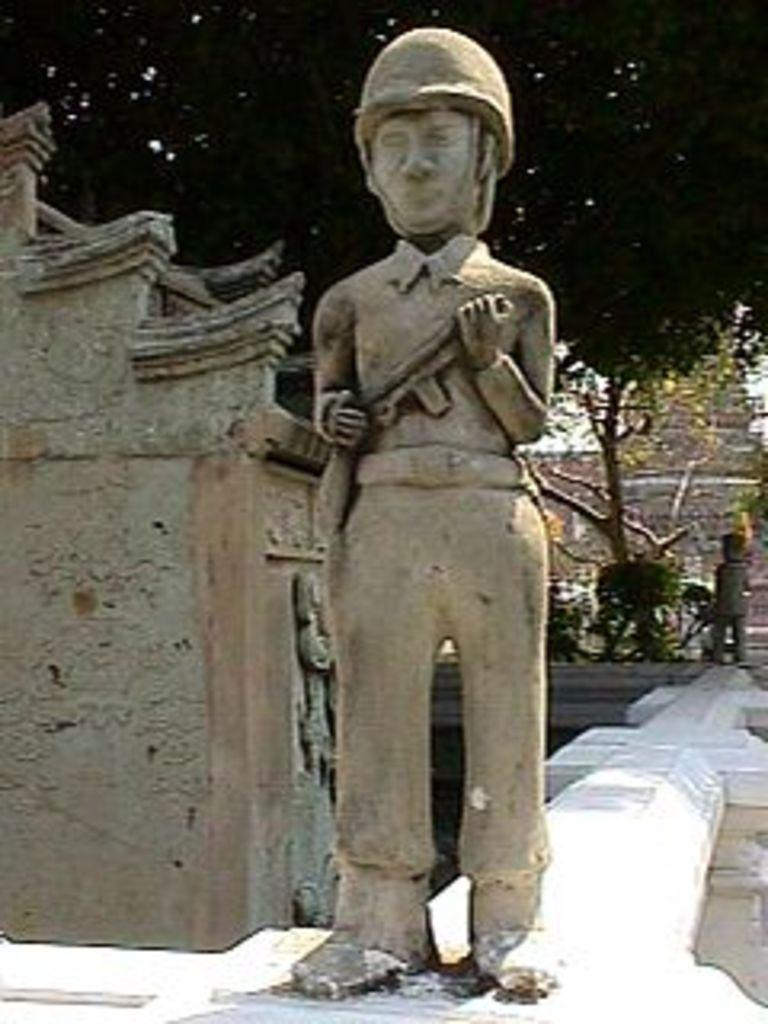What can be seen on the wall in the image? There are statues on the wall in the image. What type of structure is visible in the image? There is a structure that looks like a wall in the image. What can be seen in the background of the image? There are trees in the background of the image. Can you hear a whistle in the image? There is no mention of a whistle in the image, so it cannot be heard. Is there a lift present in the image? There is no mention of a lift in the image, so it cannot be seen. 